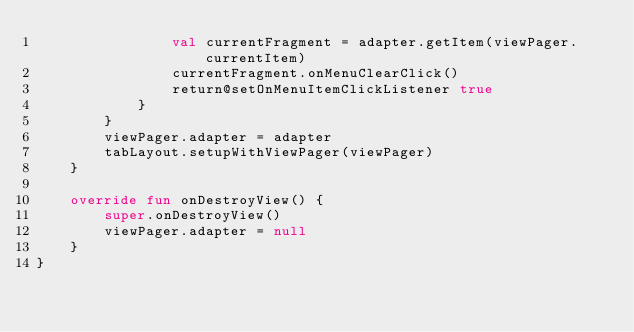<code> <loc_0><loc_0><loc_500><loc_500><_Kotlin_>                val currentFragment = adapter.getItem(viewPager.currentItem)
                currentFragment.onMenuClearClick()
                return@setOnMenuItemClickListener true
            }
        }
        viewPager.adapter = adapter
        tabLayout.setupWithViewPager(viewPager)
    }

    override fun onDestroyView() {
        super.onDestroyView()
        viewPager.adapter = null
    }
}</code> 